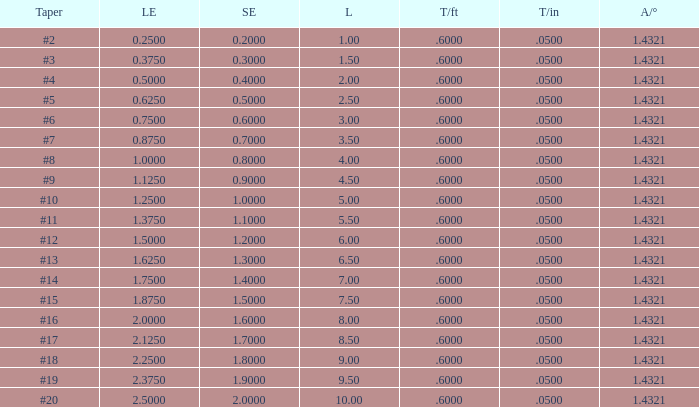Which large end features a taper per foot less than 0.6000000000000001? 19.0. 